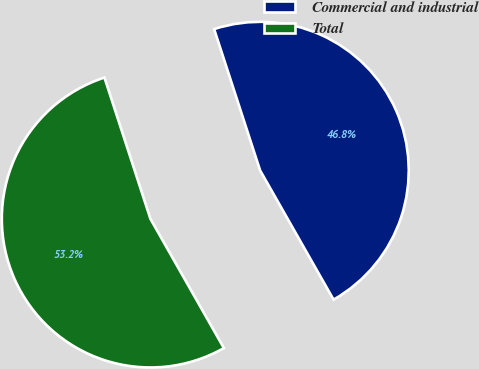Convert chart to OTSL. <chart><loc_0><loc_0><loc_500><loc_500><pie_chart><fcel>Commercial and industrial<fcel>Total<nl><fcel>46.78%<fcel>53.22%<nl></chart> 